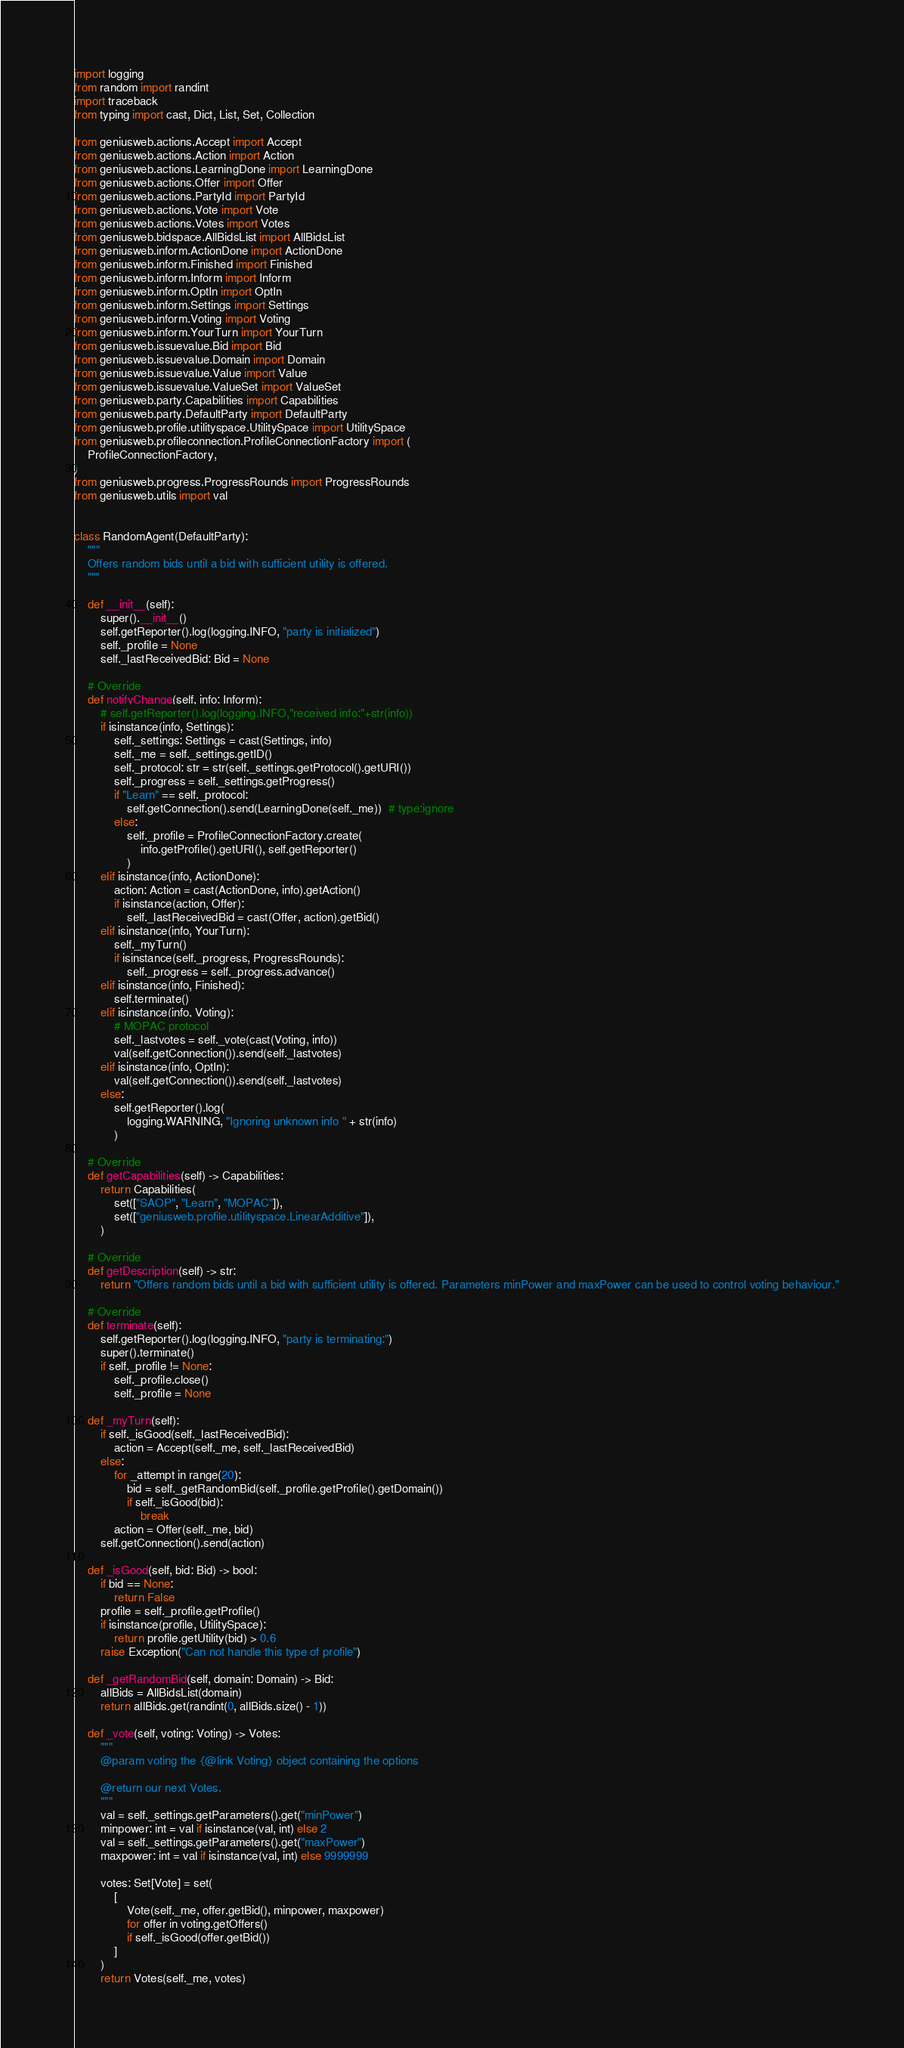Convert code to text. <code><loc_0><loc_0><loc_500><loc_500><_Python_>import logging
from random import randint
import traceback
from typing import cast, Dict, List, Set, Collection

from geniusweb.actions.Accept import Accept
from geniusweb.actions.Action import Action
from geniusweb.actions.LearningDone import LearningDone
from geniusweb.actions.Offer import Offer
from geniusweb.actions.PartyId import PartyId
from geniusweb.actions.Vote import Vote
from geniusweb.actions.Votes import Votes
from geniusweb.bidspace.AllBidsList import AllBidsList
from geniusweb.inform.ActionDone import ActionDone
from geniusweb.inform.Finished import Finished
from geniusweb.inform.Inform import Inform
from geniusweb.inform.OptIn import OptIn
from geniusweb.inform.Settings import Settings
from geniusweb.inform.Voting import Voting
from geniusweb.inform.YourTurn import YourTurn
from geniusweb.issuevalue.Bid import Bid
from geniusweb.issuevalue.Domain import Domain
from geniusweb.issuevalue.Value import Value
from geniusweb.issuevalue.ValueSet import ValueSet
from geniusweb.party.Capabilities import Capabilities
from geniusweb.party.DefaultParty import DefaultParty
from geniusweb.profile.utilityspace.UtilitySpace import UtilitySpace
from geniusweb.profileconnection.ProfileConnectionFactory import (
    ProfileConnectionFactory,
)
from geniusweb.progress.ProgressRounds import ProgressRounds
from geniusweb.utils import val


class RandomAgent(DefaultParty):
    """
    Offers random bids until a bid with sufficient utility is offered.
    """

    def __init__(self):
        super().__init__()
        self.getReporter().log(logging.INFO, "party is initialized")
        self._profile = None
        self._lastReceivedBid: Bid = None

    # Override
    def notifyChange(self, info: Inform):
        # self.getReporter().log(logging.INFO,"received info:"+str(info))
        if isinstance(info, Settings):
            self._settings: Settings = cast(Settings, info)
            self._me = self._settings.getID()
            self._protocol: str = str(self._settings.getProtocol().getURI())
            self._progress = self._settings.getProgress()
            if "Learn" == self._protocol:
                self.getConnection().send(LearningDone(self._me))  # type:ignore
            else:
                self._profile = ProfileConnectionFactory.create(
                    info.getProfile().getURI(), self.getReporter()
                )
        elif isinstance(info, ActionDone):
            action: Action = cast(ActionDone, info).getAction()
            if isinstance(action, Offer):
                self._lastReceivedBid = cast(Offer, action).getBid()
        elif isinstance(info, YourTurn):
            self._myTurn()
            if isinstance(self._progress, ProgressRounds):
                self._progress = self._progress.advance()
        elif isinstance(info, Finished):
            self.terminate()
        elif isinstance(info, Voting):
            # MOPAC protocol
            self._lastvotes = self._vote(cast(Voting, info))
            val(self.getConnection()).send(self._lastvotes)
        elif isinstance(info, OptIn):
            val(self.getConnection()).send(self._lastvotes)
        else:
            self.getReporter().log(
                logging.WARNING, "Ignoring unknown info " + str(info)
            )

    # Override
    def getCapabilities(self) -> Capabilities:
        return Capabilities(
            set(["SAOP", "Learn", "MOPAC"]),
            set(["geniusweb.profile.utilityspace.LinearAdditive"]),
        )

    # Override
    def getDescription(self) -> str:
        return "Offers random bids until a bid with sufficient utility is offered. Parameters minPower and maxPower can be used to control voting behaviour."

    # Override
    def terminate(self):
        self.getReporter().log(logging.INFO, "party is terminating:")
        super().terminate()
        if self._profile != None:
            self._profile.close()
            self._profile = None

    def _myTurn(self):
        if self._isGood(self._lastReceivedBid):
            action = Accept(self._me, self._lastReceivedBid)
        else:
            for _attempt in range(20):
                bid = self._getRandomBid(self._profile.getProfile().getDomain())
                if self._isGood(bid):
                    break
            action = Offer(self._me, bid)
        self.getConnection().send(action)

    def _isGood(self, bid: Bid) -> bool:
        if bid == None:
            return False
        profile = self._profile.getProfile()
        if isinstance(profile, UtilitySpace):
            return profile.getUtility(bid) > 0.6
        raise Exception("Can not handle this type of profile")

    def _getRandomBid(self, domain: Domain) -> Bid:
        allBids = AllBidsList(domain)
        return allBids.get(randint(0, allBids.size() - 1))

    def _vote(self, voting: Voting) -> Votes:
        """
        @param voting the {@link Voting} object containing the options

        @return our next Votes.
        """
        val = self._settings.getParameters().get("minPower")
        minpower: int = val if isinstance(val, int) else 2
        val = self._settings.getParameters().get("maxPower")
        maxpower: int = val if isinstance(val, int) else 9999999

        votes: Set[Vote] = set(
            [
                Vote(self._me, offer.getBid(), minpower, maxpower)
                for offer in voting.getOffers()
                if self._isGood(offer.getBid())
            ]
        )
        return Votes(self._me, votes)
</code> 